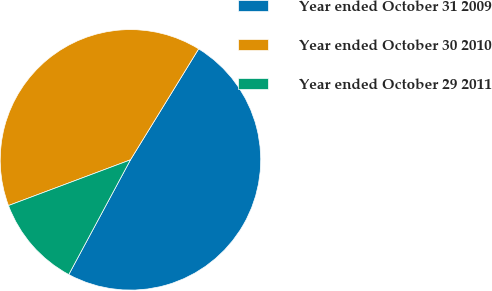<chart> <loc_0><loc_0><loc_500><loc_500><pie_chart><fcel>Year ended October 31 2009<fcel>Year ended October 30 2010<fcel>Year ended October 29 2011<nl><fcel>49.08%<fcel>39.48%<fcel>11.44%<nl></chart> 